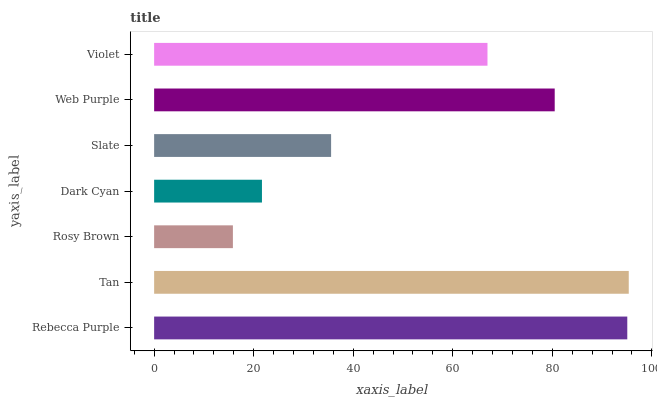Is Rosy Brown the minimum?
Answer yes or no. Yes. Is Tan the maximum?
Answer yes or no. Yes. Is Tan the minimum?
Answer yes or no. No. Is Rosy Brown the maximum?
Answer yes or no. No. Is Tan greater than Rosy Brown?
Answer yes or no. Yes. Is Rosy Brown less than Tan?
Answer yes or no. Yes. Is Rosy Brown greater than Tan?
Answer yes or no. No. Is Tan less than Rosy Brown?
Answer yes or no. No. Is Violet the high median?
Answer yes or no. Yes. Is Violet the low median?
Answer yes or no. Yes. Is Web Purple the high median?
Answer yes or no. No. Is Rebecca Purple the low median?
Answer yes or no. No. 